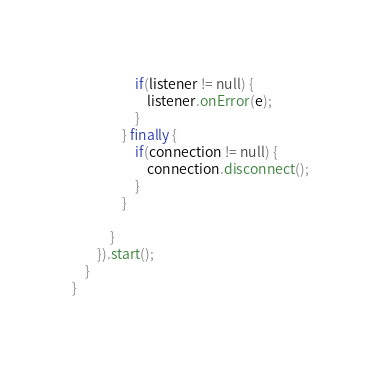<code> <loc_0><loc_0><loc_500><loc_500><_Java_>					if(listener != null) {
						listener.onError(e);
					}
				} finally {
					if(connection != null) {
						connection.disconnect();
					}
				}
				
			}
		}).start();
	}
}
</code> 